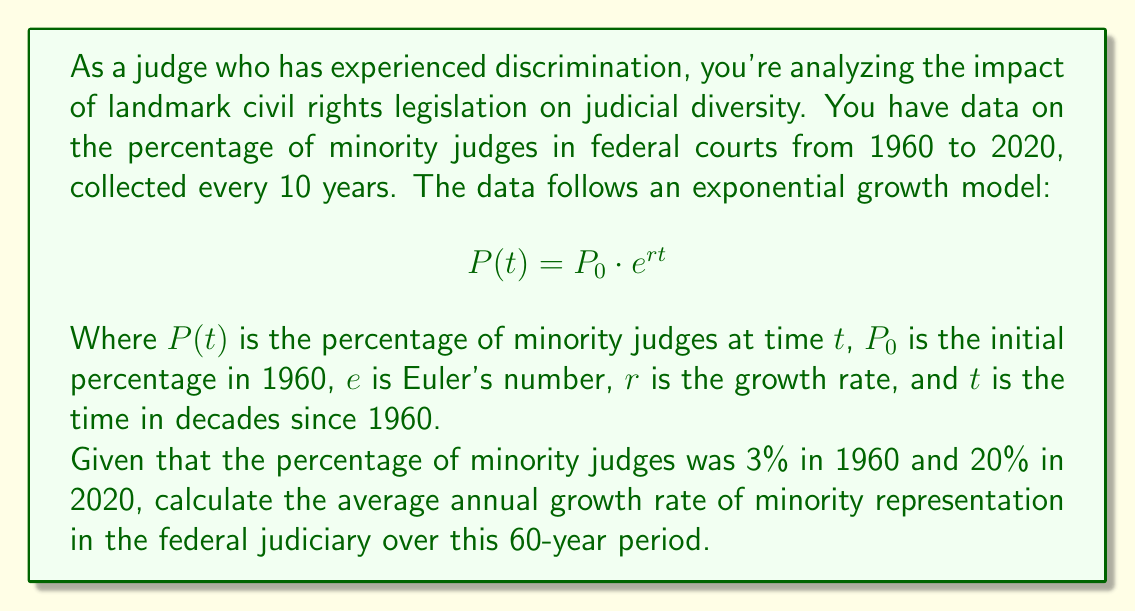Solve this math problem. To solve this problem, we'll use the exponential growth formula and the given data to find the growth rate $r$. Then we'll convert it to an annual rate.

1. We know:
   $P_0 = 3\%$ (initial percentage in 1960)
   $P(6) = 20\%$ (percentage after 6 decades, in 2020)
   $t = 6$ (time in decades)

2. Let's plug these into the formula:
   $P(t) = P_0 \cdot e^{rt}$
   $20 = 3 \cdot e^{6r}$

3. Divide both sides by 3:
   $\frac{20}{3} = e^{6r}$

4. Take the natural log of both sides:
   $\ln(\frac{20}{3}) = 6r$

5. Solve for $r$:
   $r = \frac{\ln(\frac{20}{3})}{6}$

6. Calculate $r$:
   $r = \frac{\ln(6.67)}{6} \approx 0.3155$ per decade

7. Convert to annual rate:
   Annual rate $= (e^r)^{\frac{1}{10}} - 1$
   $= (e^{0.3155})^{0.1} - 1$
   $\approx 0.0370$ or 3.70% per year

Therefore, the average annual growth rate of minority representation in the federal judiciary from 1960 to 2020 was approximately 3.70%.
Answer: The average annual growth rate of minority representation in the federal judiciary from 1960 to 2020 was approximately 3.70%. 